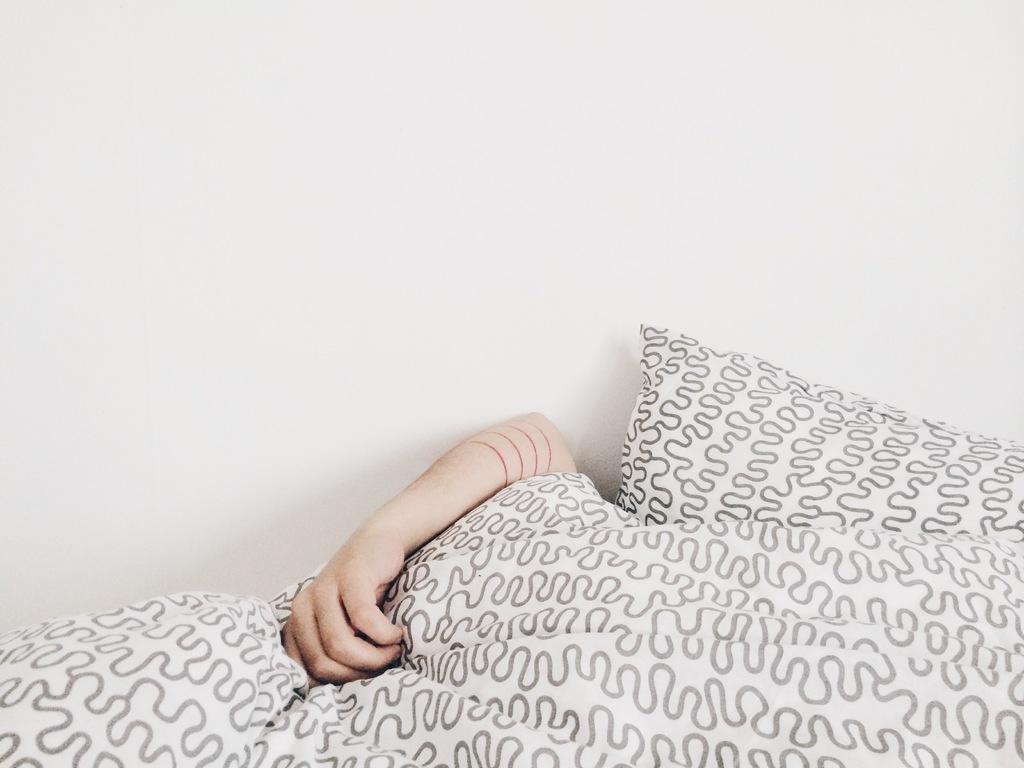What body part is visible in the image? There is a person's hand in the image. What object is present on the bed in the image? There is a pillow in the image. What type of fabric is covering the bed? There is a bed sheet in the image. What can be seen in the background of the image? There is a wall visible in the background of the image. Can you see the lunchroom through the window in the image? There is no window present in the image, so it is not possible to see the lunchroom through it. 